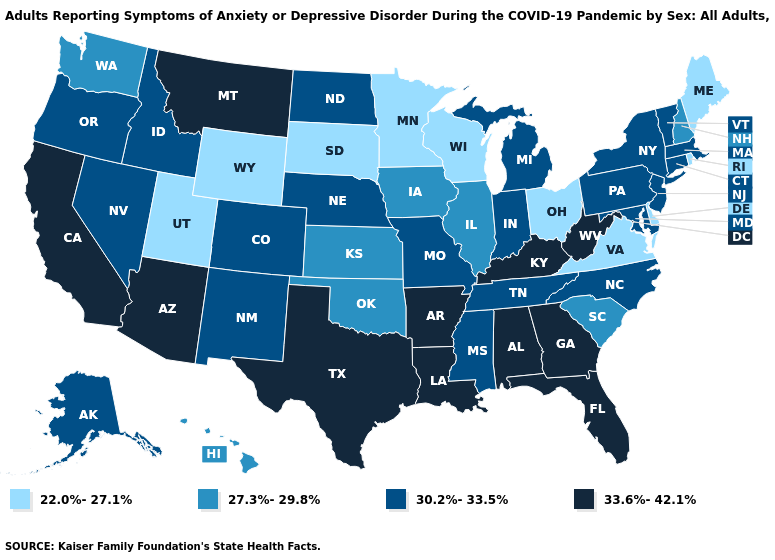What is the highest value in the MidWest ?
Answer briefly. 30.2%-33.5%. Among the states that border Massachusetts , does Connecticut have the highest value?
Short answer required. Yes. What is the value of Wisconsin?
Quick response, please. 22.0%-27.1%. How many symbols are there in the legend?
Answer briefly. 4. Name the states that have a value in the range 22.0%-27.1%?
Short answer required. Delaware, Maine, Minnesota, Ohio, Rhode Island, South Dakota, Utah, Virginia, Wisconsin, Wyoming. What is the lowest value in states that border Maryland?
Short answer required. 22.0%-27.1%. Name the states that have a value in the range 30.2%-33.5%?
Short answer required. Alaska, Colorado, Connecticut, Idaho, Indiana, Maryland, Massachusetts, Michigan, Mississippi, Missouri, Nebraska, Nevada, New Jersey, New Mexico, New York, North Carolina, North Dakota, Oregon, Pennsylvania, Tennessee, Vermont. Does Connecticut have the same value as Mississippi?
Short answer required. Yes. What is the value of Iowa?
Write a very short answer. 27.3%-29.8%. What is the value of Nevada?
Keep it brief. 30.2%-33.5%. Does New Jersey have a higher value than California?
Short answer required. No. Name the states that have a value in the range 30.2%-33.5%?
Concise answer only. Alaska, Colorado, Connecticut, Idaho, Indiana, Maryland, Massachusetts, Michigan, Mississippi, Missouri, Nebraska, Nevada, New Jersey, New Mexico, New York, North Carolina, North Dakota, Oregon, Pennsylvania, Tennessee, Vermont. What is the value of Massachusetts?
Short answer required. 30.2%-33.5%. Name the states that have a value in the range 27.3%-29.8%?
Write a very short answer. Hawaii, Illinois, Iowa, Kansas, New Hampshire, Oklahoma, South Carolina, Washington. Among the states that border Mississippi , which have the highest value?
Concise answer only. Alabama, Arkansas, Louisiana. 